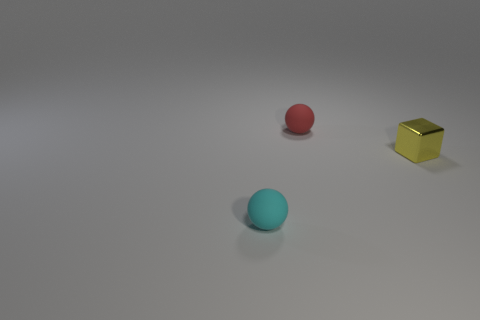Is there anything else that is the same shape as the yellow metal thing?
Ensure brevity in your answer.  No. Are there fewer tiny spheres than things?
Your response must be concise. Yes. What material is the tiny object that is left of the small metallic block and on the right side of the cyan ball?
Your answer should be compact. Rubber. Is there a small rubber thing behind the small thing that is on the right side of the red matte object?
Provide a succinct answer. Yes. What number of things are matte cubes or tiny yellow shiny blocks?
Provide a succinct answer. 1. What shape is the small object that is behind the cyan sphere and left of the small cube?
Keep it short and to the point. Sphere. Is the sphere that is right of the small cyan sphere made of the same material as the cyan object?
Offer a very short reply. Yes. How many objects are either tiny red matte balls or objects in front of the metal thing?
Keep it short and to the point. 2. What color is the other object that is made of the same material as the tiny cyan thing?
Your response must be concise. Red. What number of tiny cyan spheres are the same material as the tiny yellow object?
Offer a very short reply. 0. 